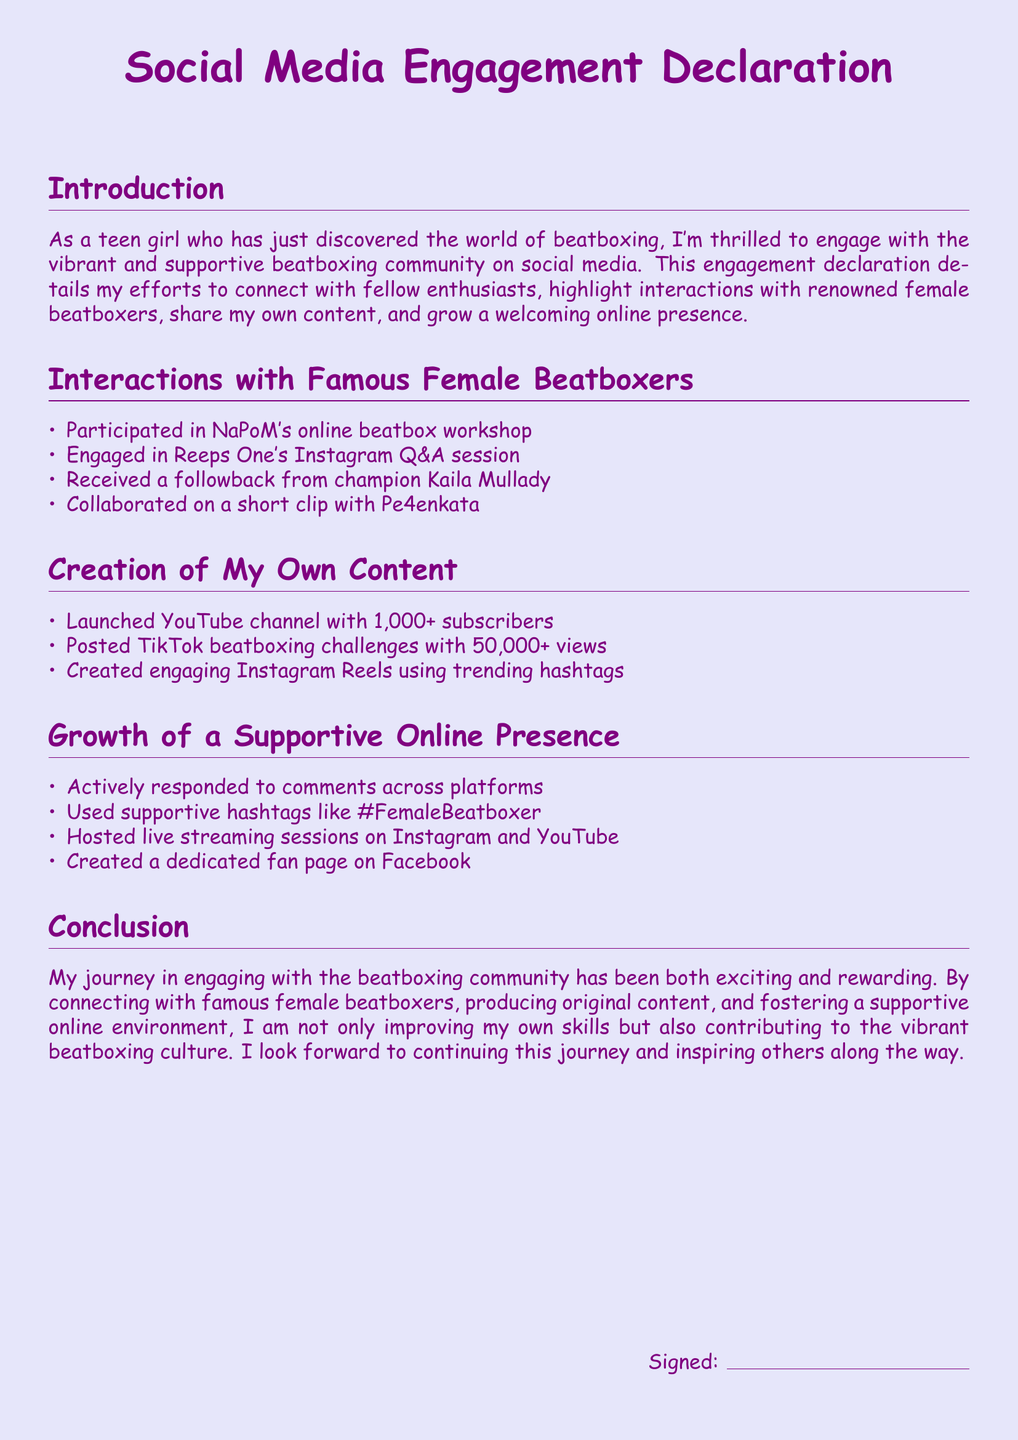What is the title of the document? The title is centered at the top of the document, indicating the main subject of the text.
Answer: Social Media Engagement Declaration How many subscribers are on the YouTube channel? The document states the number of subscribers on the YouTube channel in the section about personal content creation.
Answer: 1,000+ Which famous beatboxer followed back the author? This detail is specified in the section discussing interactions with renowned female beatboxers.
Answer: Kaila Mullady What platform hosted the live streaming sessions? The document mentions this detail in the section on growing a supportive online presence.
Answer: Instagram and YouTube How many views did the TikTok beatboxing challenges receive? This number is mentioned in the creation of personal content subsection of the document.
Answer: 50,000+ What was one of the supportive hashtags used? The document provides examples of supportive hashtags in the section on building a supportive online presence.
Answer: #FemaleBeatboxer Which female beatboxer collaborated on a short clip? This specific collaboration is highlighted in the section detailing interactions with famous beatboxers.
Answer: Pe4enkata What type of document is this? The structure and purpose of the text indicate its classification.
Answer: Declaration 